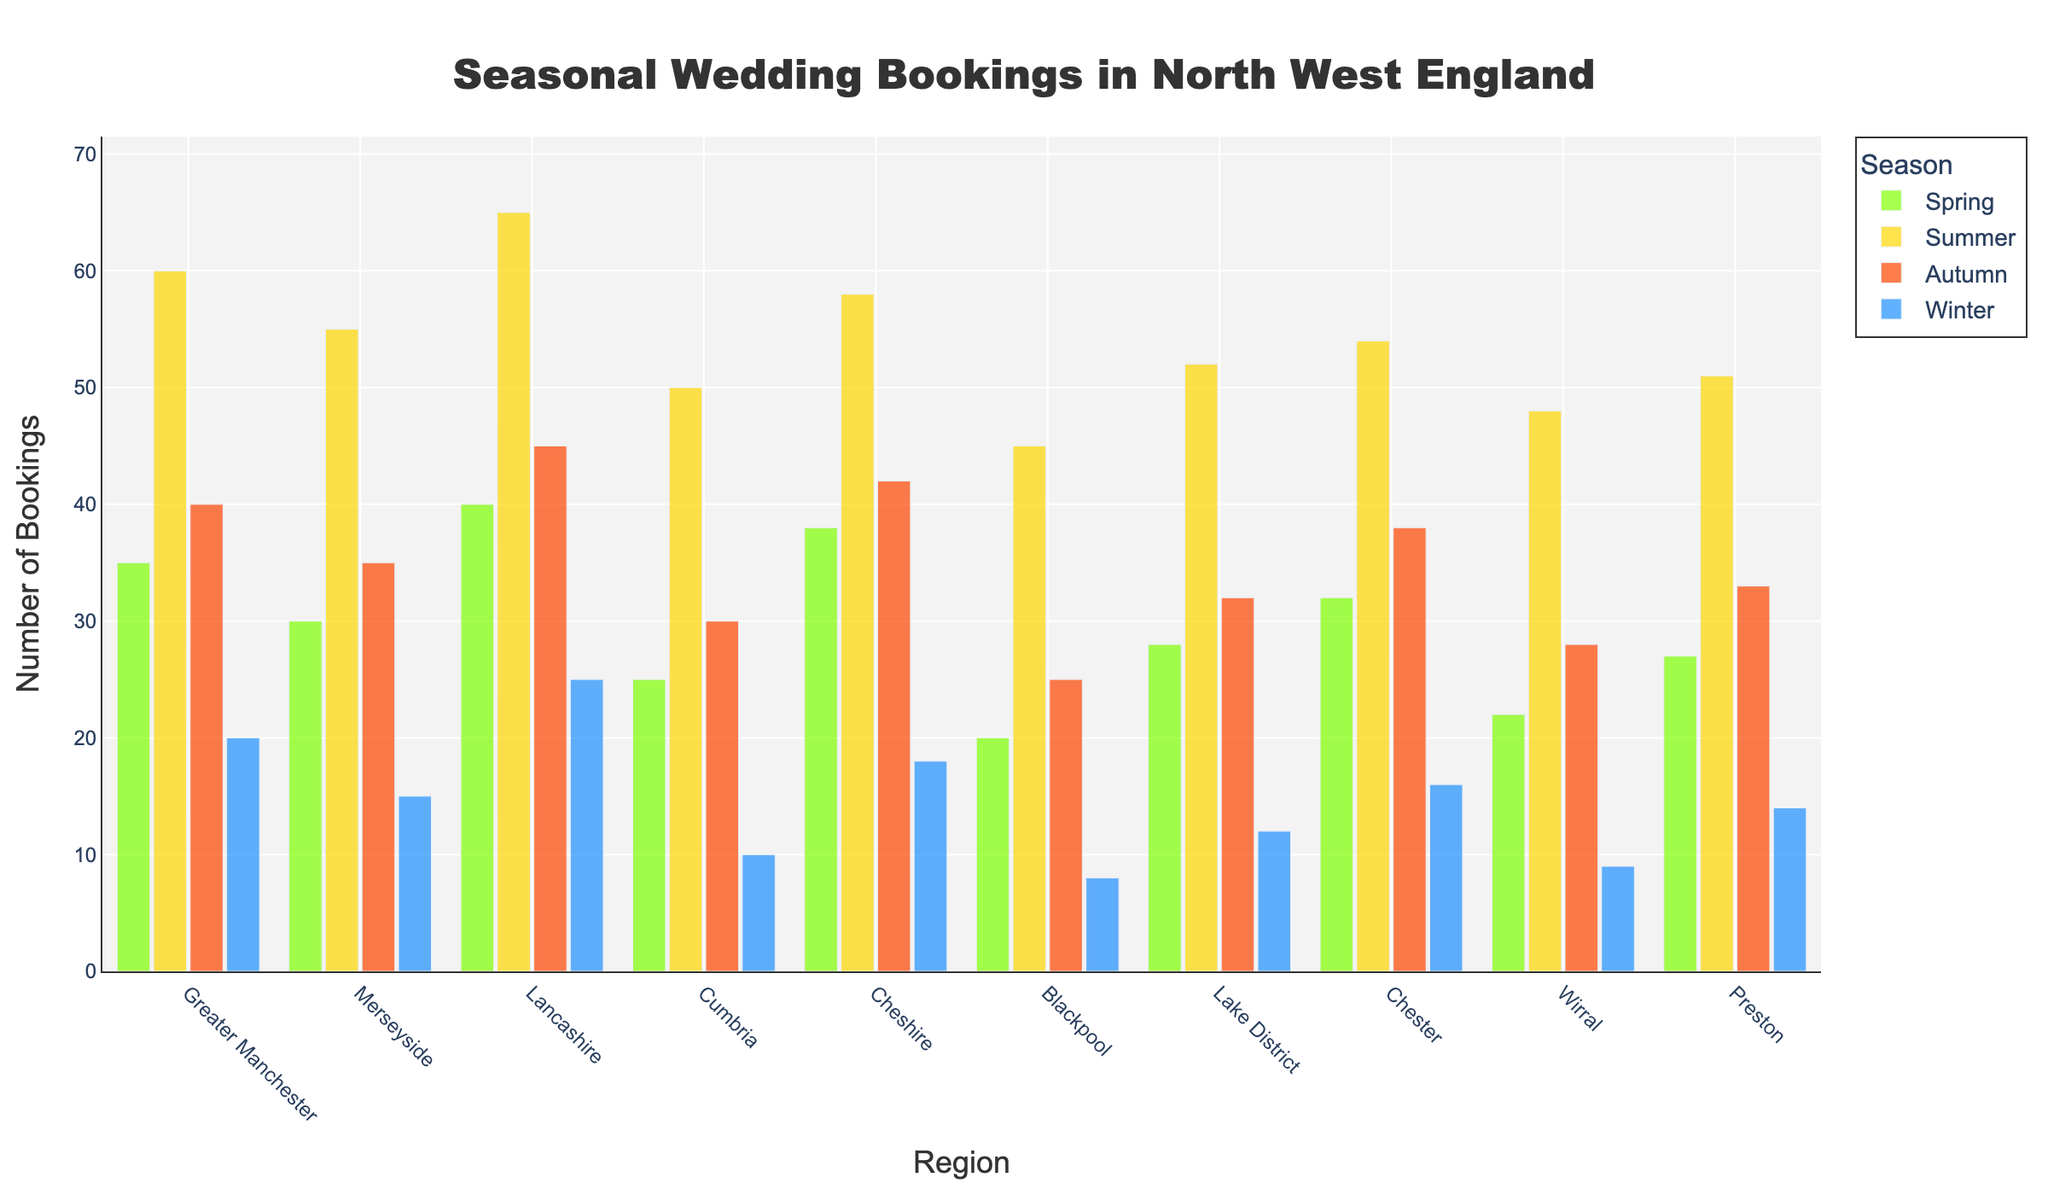What is the title of the figure? The title is usually prominently displayed at the top of the figure. It gives an overview of what the entire chart represents.
Answer: Seasonal Wedding Bookings in North West England Which season has the highest number of bookings in Greater Manchester? To determine this, look at the heights of the bars for each season in Greater Manchester. The tallest bar represents the season with the highest number of bookings.
Answer: Summer How many total bookings are there in Cheshire across all seasons? Sum the number of bookings for each season shown by each bar for Cheshire. 38 (Spring) + 58 (Summer) + 42 (Autumn) + 18 (Winter) = 156
Answer: 156 Which region has the lowest number of bookings in Winter? Compare the heights of the Winter bars across all regions. The shortest bar will show the region with the lowest number of bookings in Winter.
Answer: Blackpool What is the average number of bookings in Cumbria across all seasons? Sum the number of bookings for each season in Cumbria and divide by the number of seasons (4). (25+50+30+10)/4 = 28.75
Answer: 28.75 In which region is the difference between the highest and lowest seasonal bookings the greatest? For each region, calculate the difference between the highest and lowest seasonal booking numbers, then identify the region with the maximum difference. Lancashire's difference: 65 (Summer) - 25 (Winter) = 40; do this for all regions to find the maximum.
Answer: Lancashire Which season generally shows the highest number of bookings across all regions? Assess the height of each seasonal bar for all regions. The season with the most consistently tall bars across the regions will be the one with the highest number of bookings.
Answer: Summer Which region shows the most uniform booking pattern (least variation) across all seasons? Calculate the range (difference between maximum and minimum bookings) for each region, and identify the region with the smallest range. Wirral: 48 (Summer) - 9 (Winter) = 39, do the same for all regions.
Answer: Preston Is there any region where bookings are higher in Winter than Spring? Compare the heights of Winter and Spring bars for each region to see if Winter is higher than Spring.
Answer: No Is there a region where Autumn bookings surpass Summer bookings? For each region, check if the Autumn bar is taller than the Summer bar.
Answer: No 